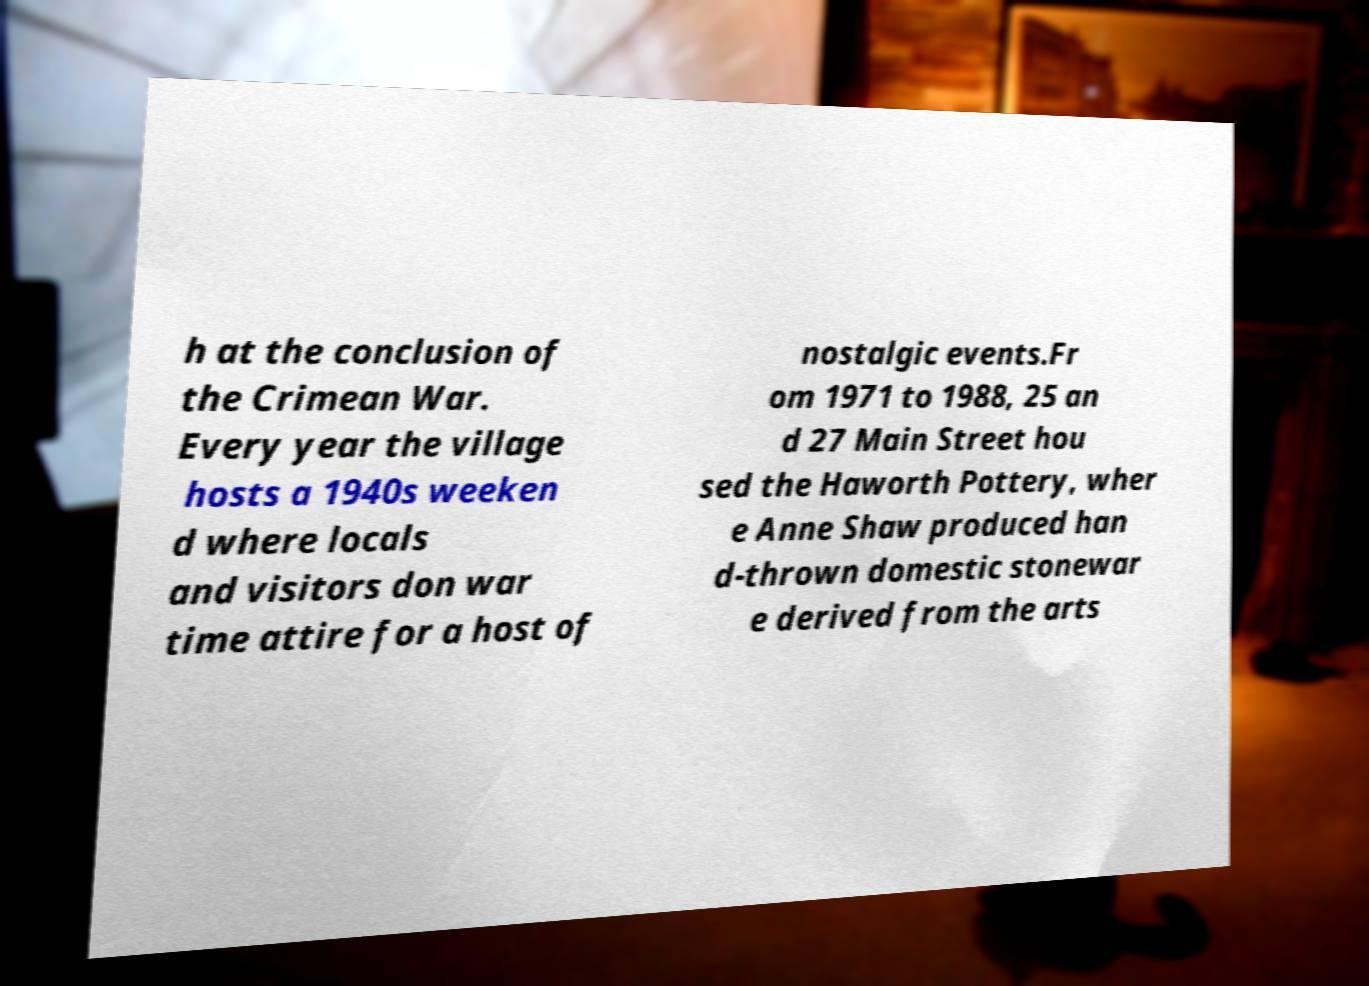Please identify and transcribe the text found in this image. h at the conclusion of the Crimean War. Every year the village hosts a 1940s weeken d where locals and visitors don war time attire for a host of nostalgic events.Fr om 1971 to 1988, 25 an d 27 Main Street hou sed the Haworth Pottery, wher e Anne Shaw produced han d-thrown domestic stonewar e derived from the arts 